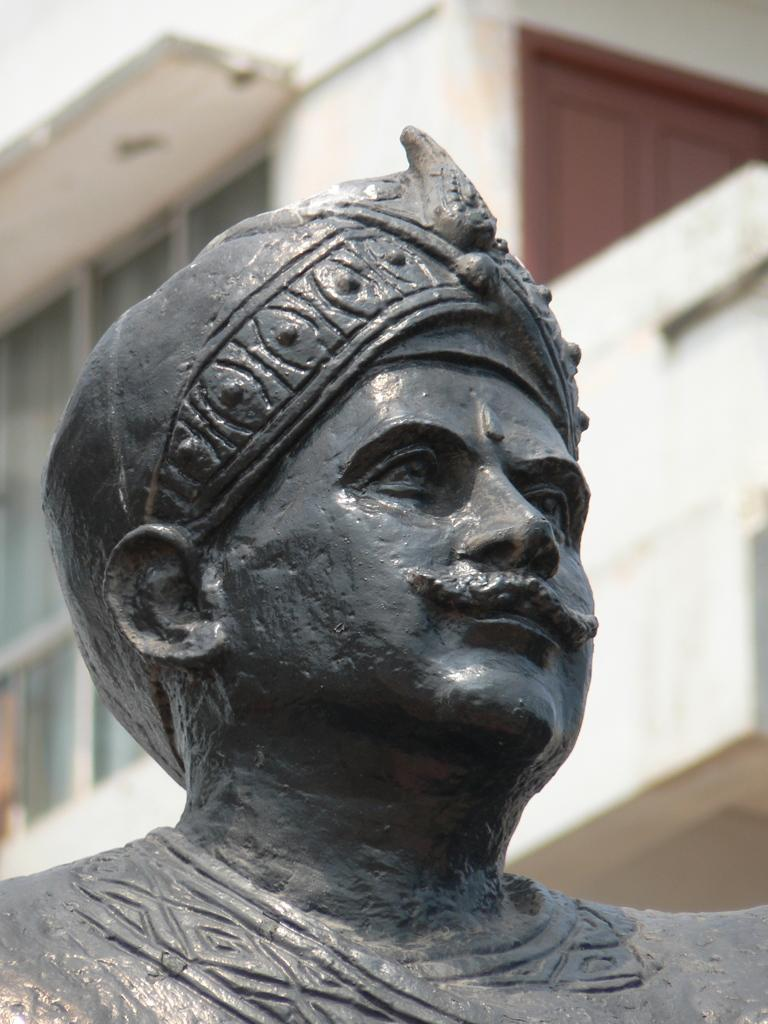What is the main subject in the foreground of the image? There is a person's statue in the foreground of the image. What can be seen in the background of the image? There is a building in the background of the image. When was the image taken? The image was taken during the day. What type of offer is the statue making to the building in the image? There is no offer being made by the statue in the image, as it is a statue and cannot make offers. 